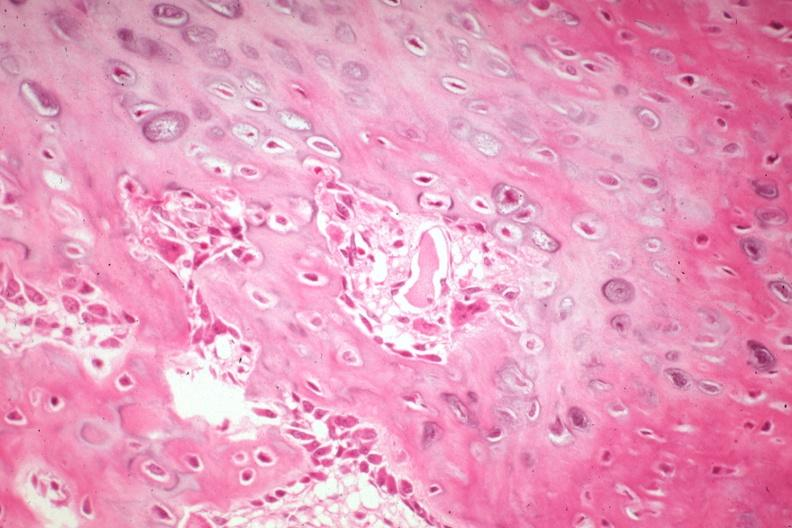what is present?
Answer the question using a single word or phrase. Joints 